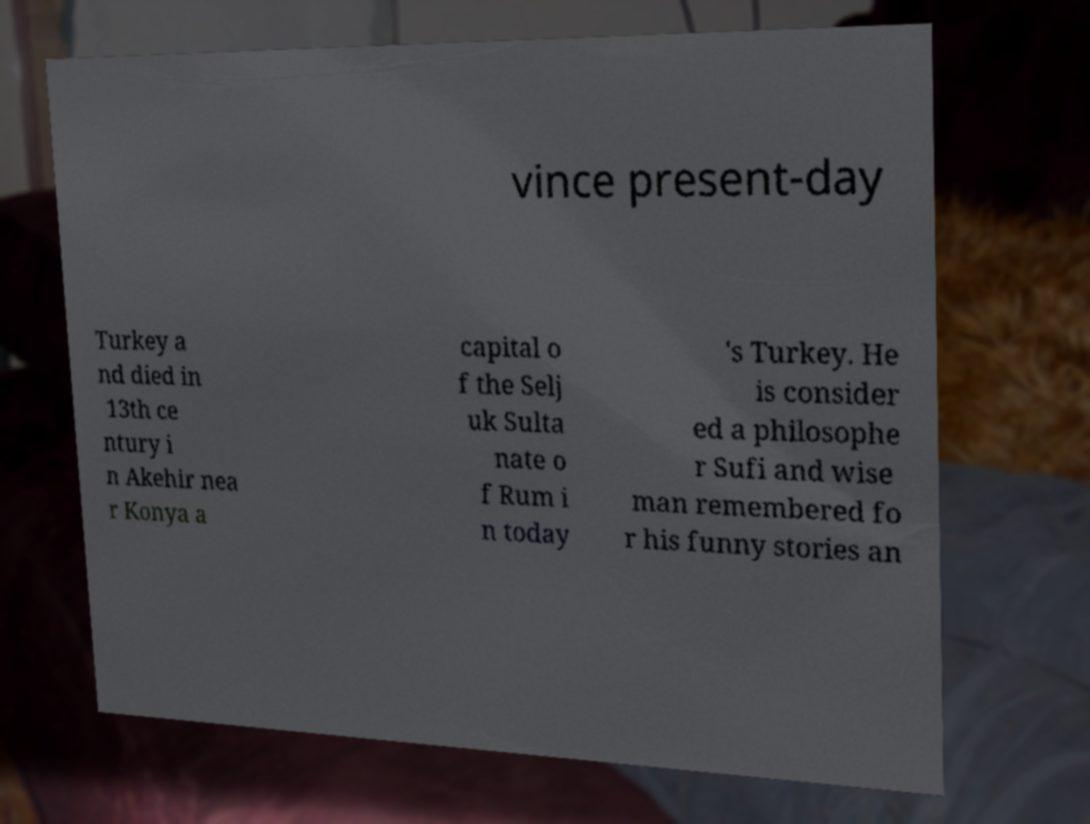Please read and relay the text visible in this image. What does it say? vince present-day Turkey a nd died in 13th ce ntury i n Akehir nea r Konya a capital o f the Selj uk Sulta nate o f Rum i n today 's Turkey. He is consider ed a philosophe r Sufi and wise man remembered fo r his funny stories an 